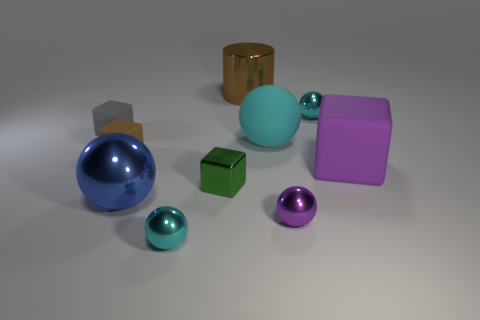Subtract all big metal spheres. How many spheres are left? 4 Subtract all blue spheres. How many spheres are left? 4 Subtract all cylinders. How many objects are left? 9 Subtract 1 cubes. How many cubes are left? 3 Subtract all metal spheres. Subtract all brown metal objects. How many objects are left? 5 Add 6 small metal objects. How many small metal objects are left? 10 Add 8 small red cubes. How many small red cubes exist? 8 Subtract 0 purple cylinders. How many objects are left? 10 Subtract all gray cubes. Subtract all purple spheres. How many cubes are left? 3 Subtract all cyan cylinders. How many green cubes are left? 1 